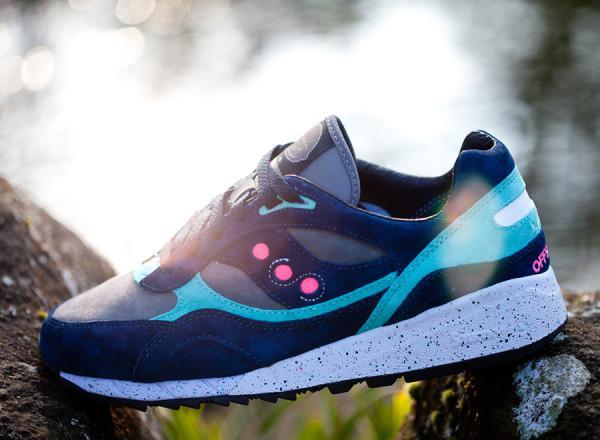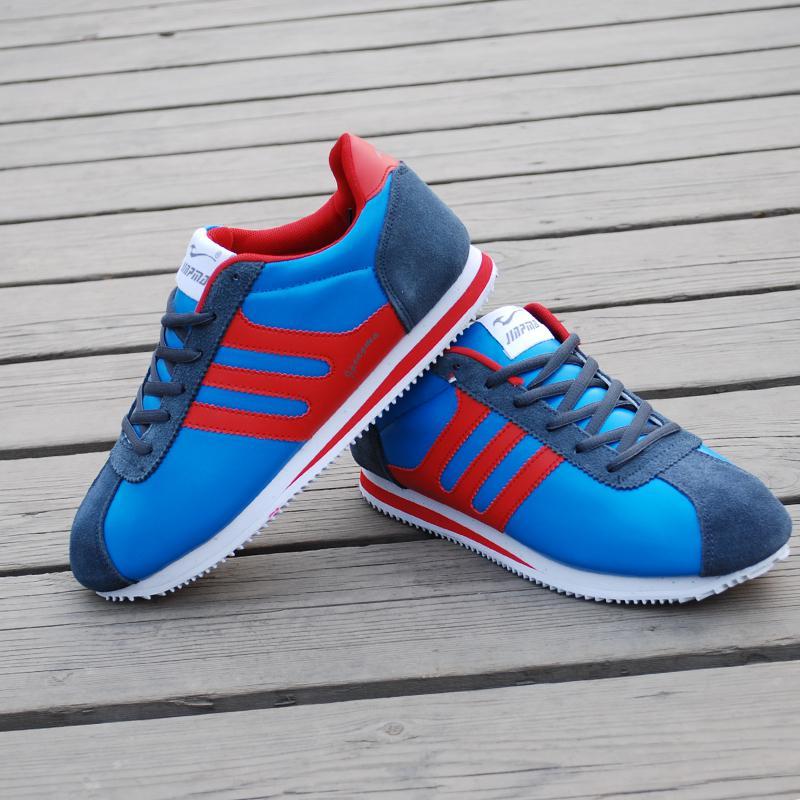The first image is the image on the left, the second image is the image on the right. Given the left and right images, does the statement "In one image, at least one shoe is being worn by a human." hold true? Answer yes or no. No. 